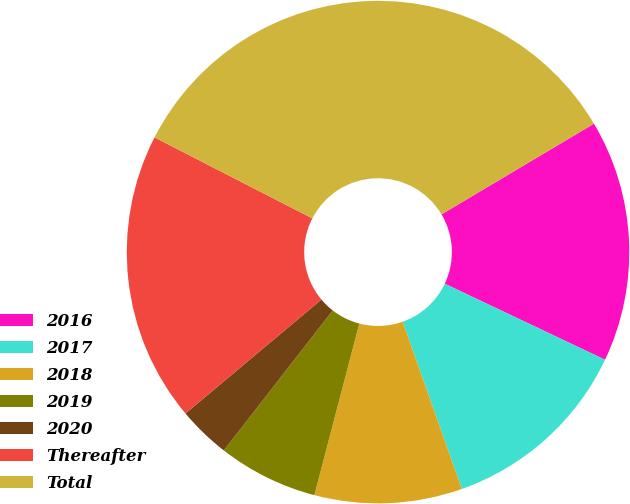<chart> <loc_0><loc_0><loc_500><loc_500><pie_chart><fcel>2016<fcel>2017<fcel>2018<fcel>2019<fcel>2020<fcel>Thereafter<fcel>Total<nl><fcel>15.59%<fcel>12.54%<fcel>9.49%<fcel>6.44%<fcel>3.38%<fcel>18.65%<fcel>33.91%<nl></chart> 